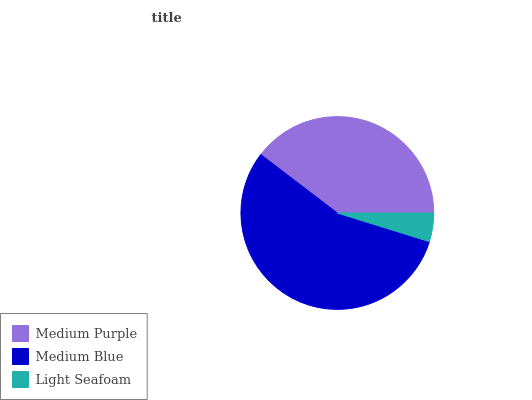Is Light Seafoam the minimum?
Answer yes or no. Yes. Is Medium Blue the maximum?
Answer yes or no. Yes. Is Medium Blue the minimum?
Answer yes or no. No. Is Light Seafoam the maximum?
Answer yes or no. No. Is Medium Blue greater than Light Seafoam?
Answer yes or no. Yes. Is Light Seafoam less than Medium Blue?
Answer yes or no. Yes. Is Light Seafoam greater than Medium Blue?
Answer yes or no. No. Is Medium Blue less than Light Seafoam?
Answer yes or no. No. Is Medium Purple the high median?
Answer yes or no. Yes. Is Medium Purple the low median?
Answer yes or no. Yes. Is Light Seafoam the high median?
Answer yes or no. No. Is Medium Blue the low median?
Answer yes or no. No. 